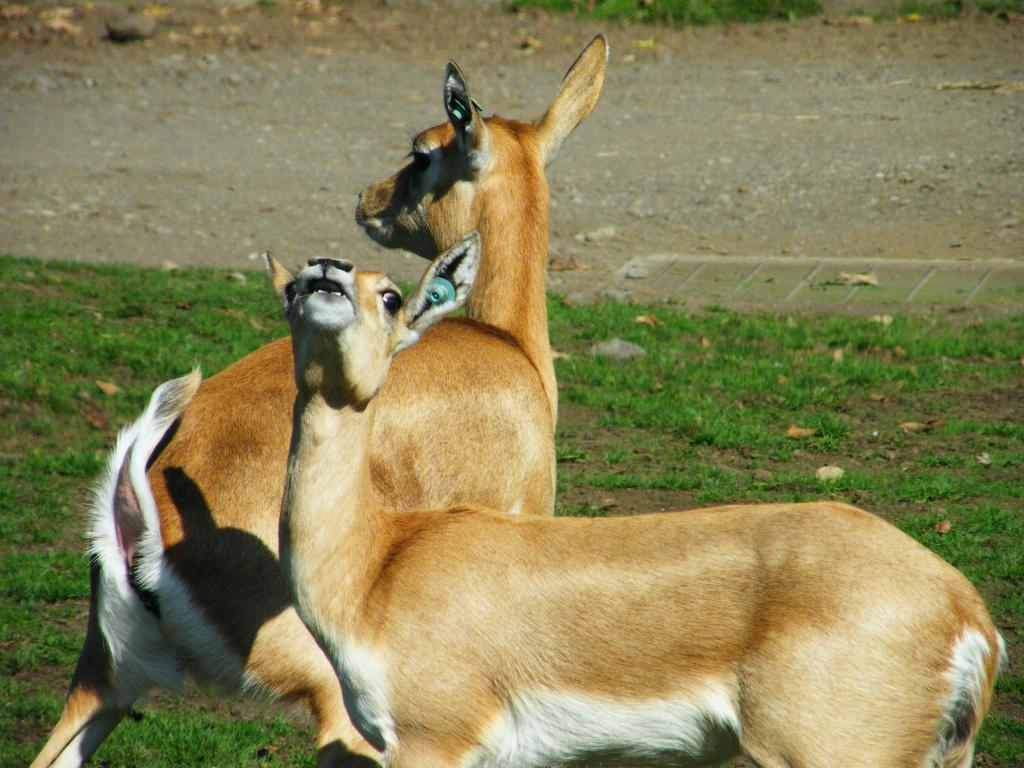How many deer are present in the image? There are two deer in the image. What type of surface are the deer standing on? The deer are standing on a grass surface. What other types of surfaces can be seen in the image? There is a sand surface and a muddy surface in the image. What type of quince is being used as a prop in the image? There is no quince present in the image. Who is the friend of the deer in the image? The image does not depict any friends of the deer, as deer are not known to have human friends. 